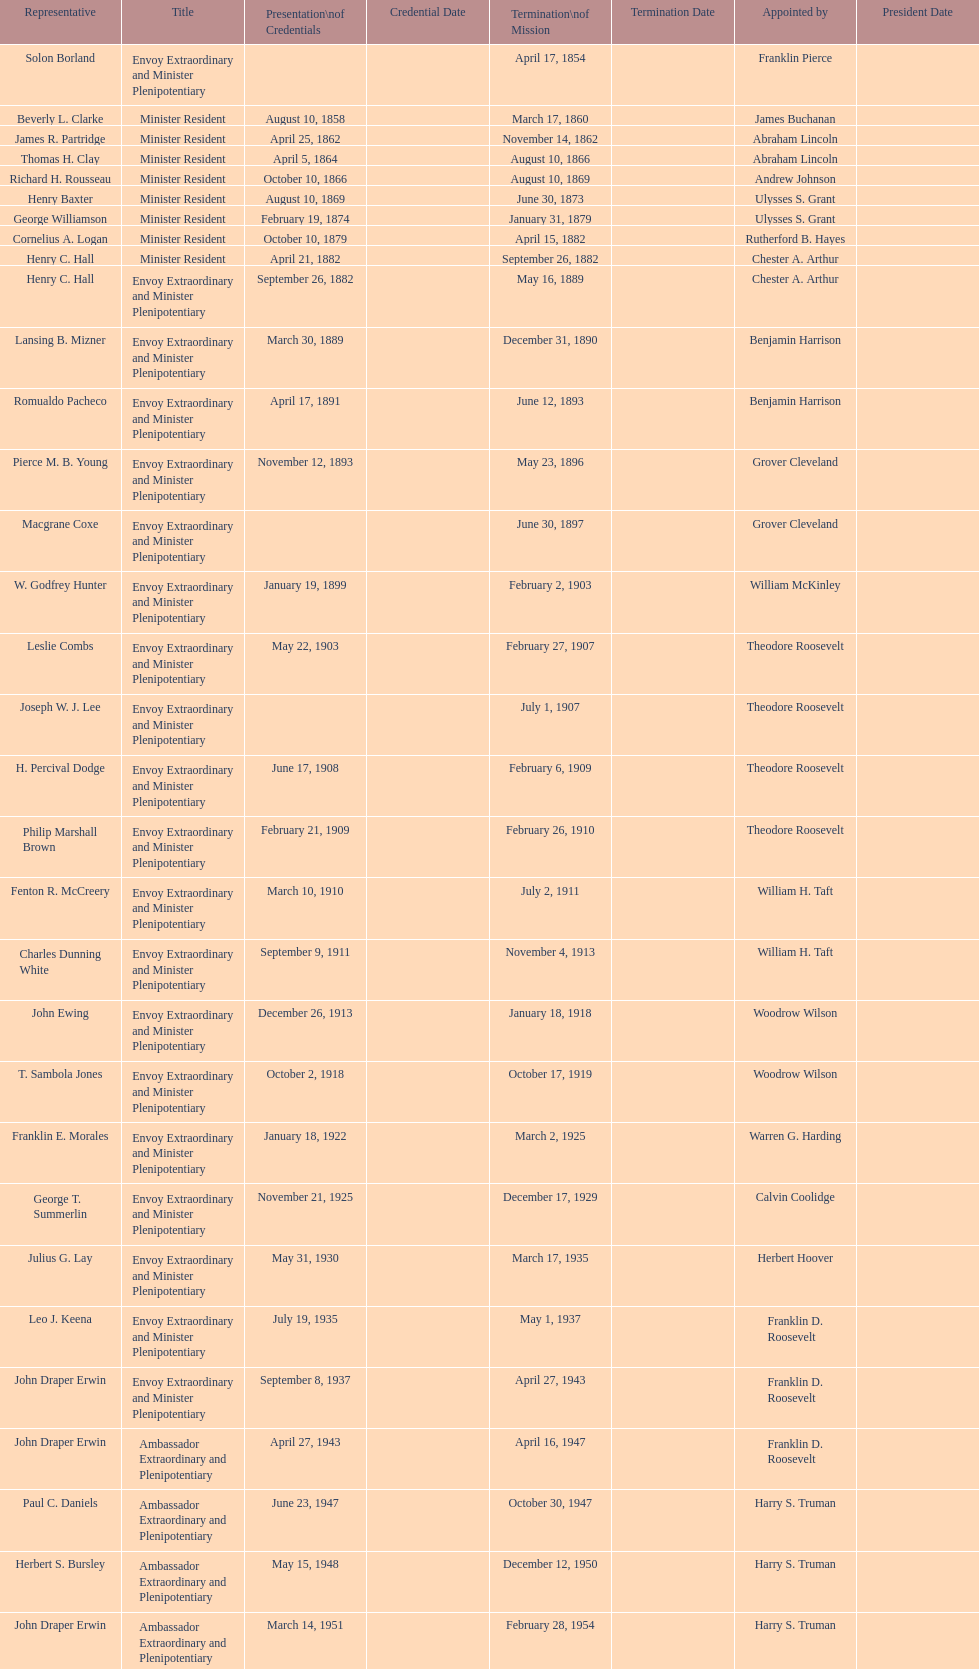Who is the only ambassadors to honduras appointed by barack obama? Lisa Kubiske. 